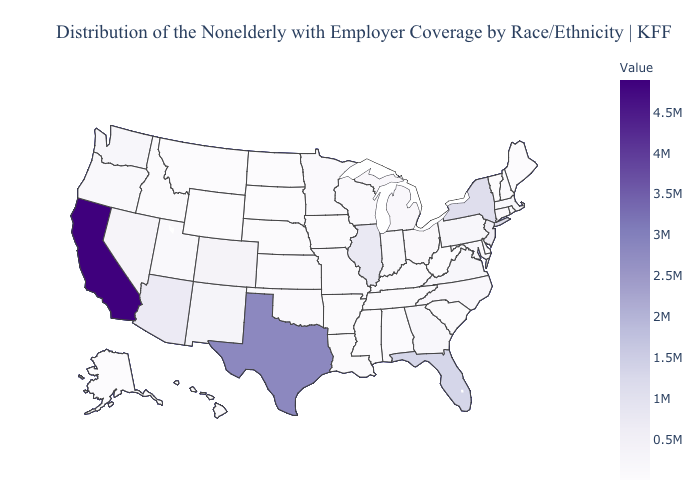Among the states that border Montana , which have the highest value?
Give a very brief answer. Idaho. Does Wisconsin have a lower value than California?
Write a very short answer. Yes. Which states have the lowest value in the MidWest?
Answer briefly. North Dakota. Among the states that border Connecticut , which have the lowest value?
Keep it brief. Rhode Island. Is the legend a continuous bar?
Give a very brief answer. Yes. Among the states that border Nebraska , does Wyoming have the lowest value?
Give a very brief answer. No. Is the legend a continuous bar?
Write a very short answer. Yes. 